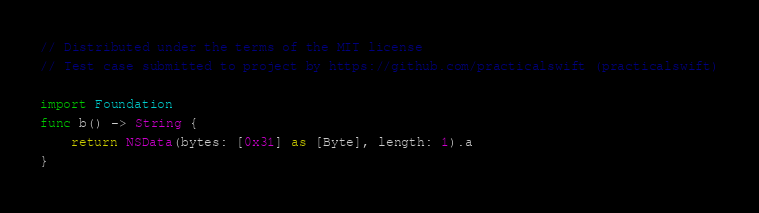Convert code to text. <code><loc_0><loc_0><loc_500><loc_500><_Swift_>// Distributed under the terms of the MIT license
// Test case submitted to project by https://github.com/practicalswift (practicalswift)

import Foundation
func b() -> String {
    return NSData(bytes: [0x31] as [Byte], length: 1).a
}
</code> 